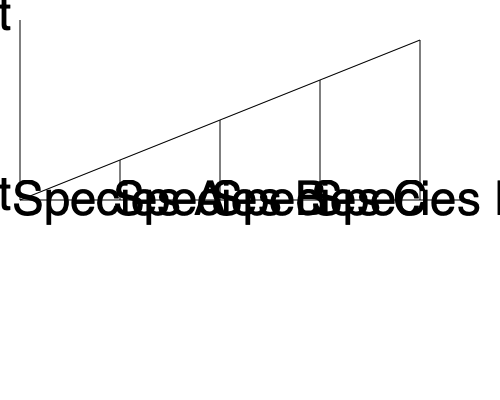Based on the phylogenetic tree diagram, which two species share the most recent common ancestor, and approximately how long ago did they diverge relative to the other speciation events shown? To answer this question, we need to analyze the phylogenetic tree diagram step by step:

1. The tree shows four species: A, B, C, and D.
2. The vertical axis represents time, with the present at the bottom and the past at the top.
3. The branching points (nodes) represent common ancestors and speciation events.
4. To find the most recent common ancestor, we look for the lowest branching point connecting two species.
5. Species C and D share the lowest branching point, indicating they have the most recent common ancestor.
6. To estimate how long ago they diverged relative to other events:
   a. There are four visible speciation events (branching points).
   b. The C-D split is the most recent (lowest on the tree).
   c. The vertical distance between branching points appears roughly equal.
   d. Counting from the present, the C-D split is at the 3rd level out of 4.
7. Therefore, the C-D split occurred approximately 1/4 of the way back in time relative to the earliest shown speciation event.
Answer: Species C and D; about 3/4 of the total time shown 